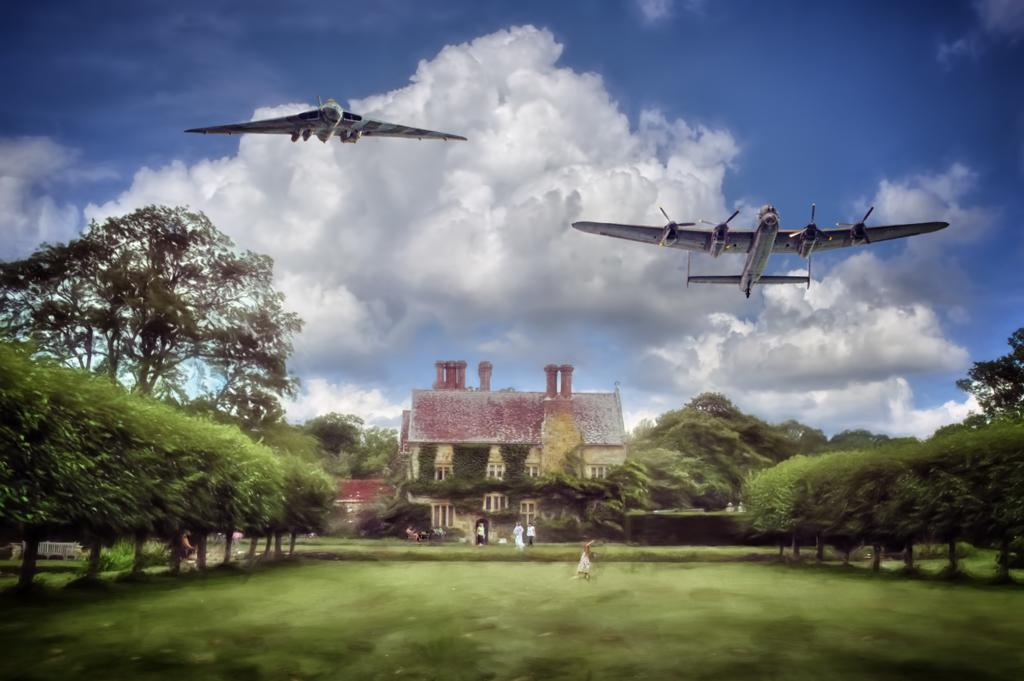What is the main structure in the center of the image? There is a shed in the center of the image. Who or what can be seen at the bottom of the image? People are visible at the bottom of the image. What type of vegetation is present in the image? There are trees in the image. What is happening in the sky in the image? Aeroplanes are flying in the sky. What part of the natural environment is visible in the image? The sky is visible in the background of the image. How many kittens are playing with dad in the image? There are no kittens or a dad present in the image. 